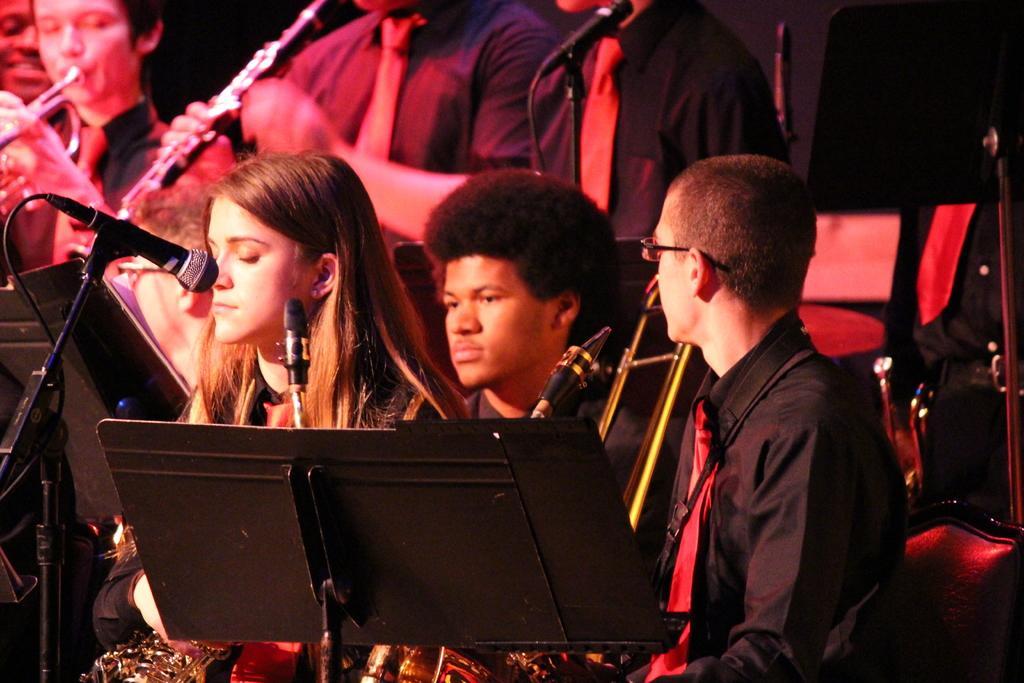How would you summarize this image in a sentence or two? In this image, we can see three persons wearing clothes and sitting in front of the mic. There are two persons in the top left of the image holding musical instruments. There is a mic at the top of the image. 